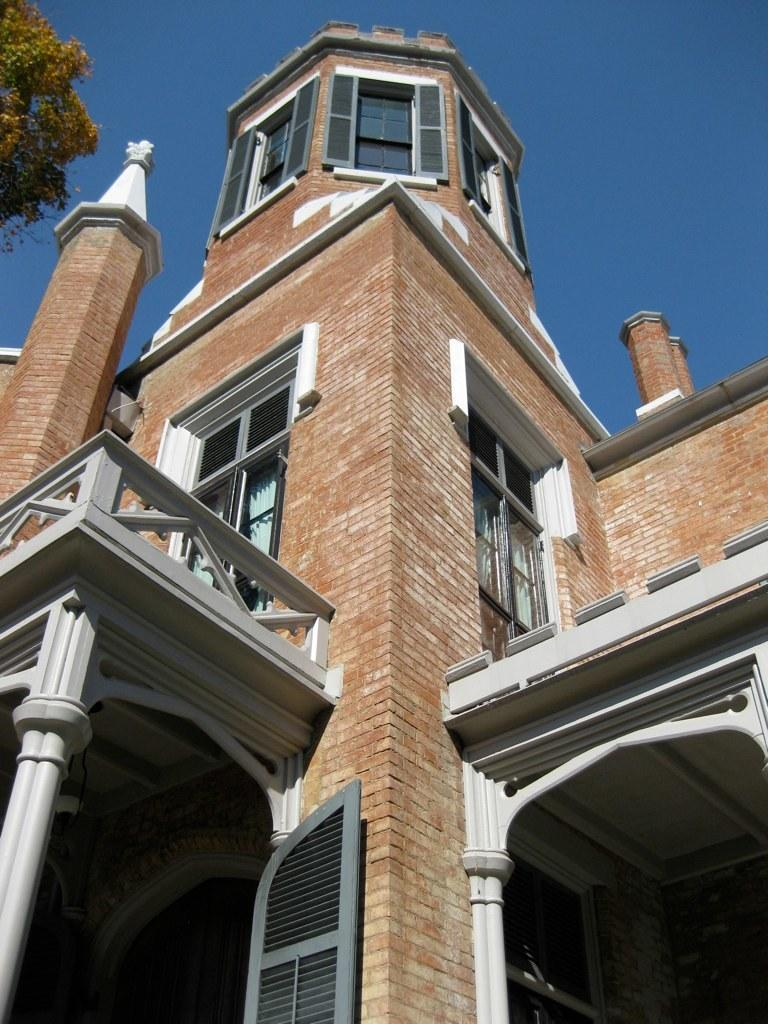What type of structure is visible in the image? There is a building in the image. What can be seen on the left side of the image? There is a tree on the left side of the image. What type of team is playing in the image? There is no team or any indication of a game or sport in the image. 